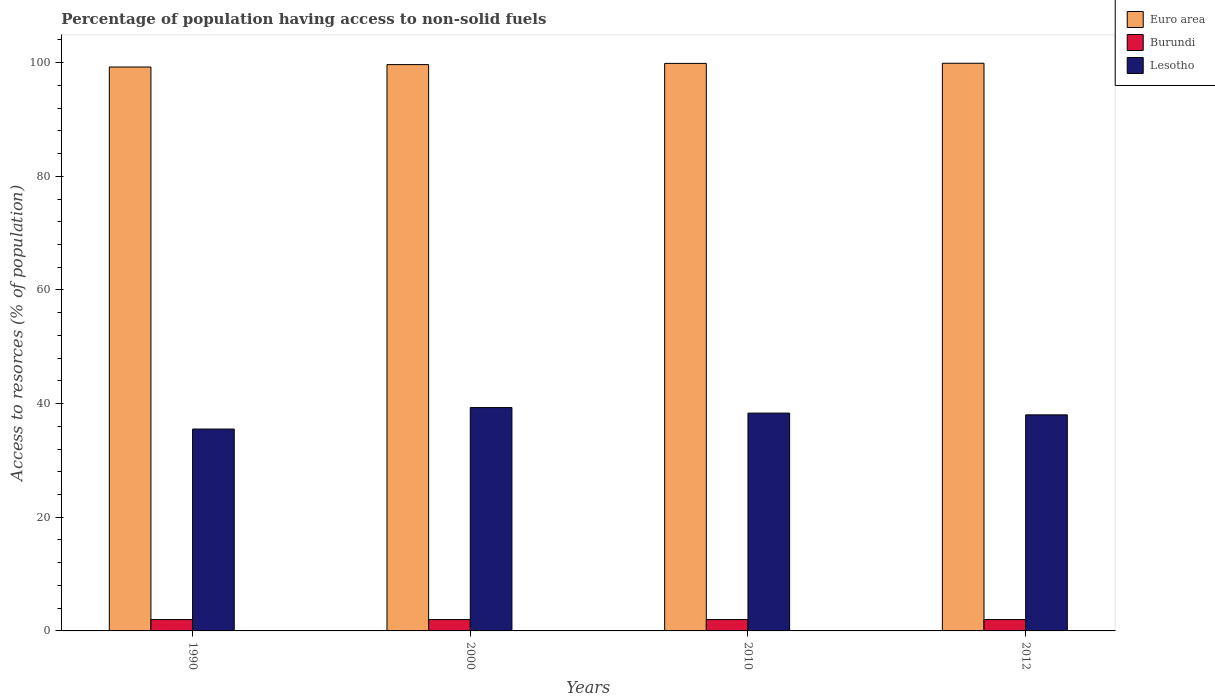How many different coloured bars are there?
Your answer should be very brief. 3. How many groups of bars are there?
Keep it short and to the point. 4. Are the number of bars per tick equal to the number of legend labels?
Provide a short and direct response. Yes. What is the label of the 4th group of bars from the left?
Your response must be concise. 2012. In how many cases, is the number of bars for a given year not equal to the number of legend labels?
Your answer should be compact. 0. What is the percentage of population having access to non-solid fuels in Burundi in 2010?
Provide a succinct answer. 2. Across all years, what is the maximum percentage of population having access to non-solid fuels in Euro area?
Provide a succinct answer. 99.89. Across all years, what is the minimum percentage of population having access to non-solid fuels in Burundi?
Your response must be concise. 2. What is the total percentage of population having access to non-solid fuels in Euro area in the graph?
Your response must be concise. 398.65. What is the difference between the percentage of population having access to non-solid fuels in Lesotho in 2010 and that in 2012?
Offer a terse response. 0.31. What is the difference between the percentage of population having access to non-solid fuels in Burundi in 2012 and the percentage of population having access to non-solid fuels in Lesotho in 1990?
Ensure brevity in your answer.  -33.52. What is the average percentage of population having access to non-solid fuels in Euro area per year?
Offer a terse response. 99.66. In the year 2010, what is the difference between the percentage of population having access to non-solid fuels in Burundi and percentage of population having access to non-solid fuels in Lesotho?
Make the answer very short. -36.33. Is the percentage of population having access to non-solid fuels in Lesotho in 2000 less than that in 2012?
Your response must be concise. No. Is the difference between the percentage of population having access to non-solid fuels in Burundi in 1990 and 2012 greater than the difference between the percentage of population having access to non-solid fuels in Lesotho in 1990 and 2012?
Provide a succinct answer. Yes. What is the difference between the highest and the lowest percentage of population having access to non-solid fuels in Lesotho?
Offer a very short reply. 3.78. Is the sum of the percentage of population having access to non-solid fuels in Euro area in 2010 and 2012 greater than the maximum percentage of population having access to non-solid fuels in Burundi across all years?
Give a very brief answer. Yes. What does the 1st bar from the right in 2010 represents?
Provide a short and direct response. Lesotho. Is it the case that in every year, the sum of the percentage of population having access to non-solid fuels in Burundi and percentage of population having access to non-solid fuels in Lesotho is greater than the percentage of population having access to non-solid fuels in Euro area?
Keep it short and to the point. No. What is the difference between two consecutive major ticks on the Y-axis?
Your response must be concise. 20. Are the values on the major ticks of Y-axis written in scientific E-notation?
Provide a succinct answer. No. What is the title of the graph?
Your response must be concise. Percentage of population having access to non-solid fuels. Does "Micronesia" appear as one of the legend labels in the graph?
Keep it short and to the point. No. What is the label or title of the Y-axis?
Make the answer very short. Access to resorces (% of population). What is the Access to resorces (% of population) of Euro area in 1990?
Offer a very short reply. 99.23. What is the Access to resorces (% of population) in Burundi in 1990?
Give a very brief answer. 2. What is the Access to resorces (% of population) of Lesotho in 1990?
Your answer should be very brief. 35.52. What is the Access to resorces (% of population) in Euro area in 2000?
Your response must be concise. 99.66. What is the Access to resorces (% of population) in Burundi in 2000?
Offer a terse response. 2. What is the Access to resorces (% of population) in Lesotho in 2000?
Provide a short and direct response. 39.3. What is the Access to resorces (% of population) in Euro area in 2010?
Provide a short and direct response. 99.87. What is the Access to resorces (% of population) of Burundi in 2010?
Keep it short and to the point. 2. What is the Access to resorces (% of population) in Lesotho in 2010?
Ensure brevity in your answer.  38.33. What is the Access to resorces (% of population) in Euro area in 2012?
Keep it short and to the point. 99.89. What is the Access to resorces (% of population) in Burundi in 2012?
Keep it short and to the point. 2. What is the Access to resorces (% of population) in Lesotho in 2012?
Make the answer very short. 38.02. Across all years, what is the maximum Access to resorces (% of population) of Euro area?
Offer a very short reply. 99.89. Across all years, what is the maximum Access to resorces (% of population) of Burundi?
Offer a very short reply. 2. Across all years, what is the maximum Access to resorces (% of population) of Lesotho?
Give a very brief answer. 39.3. Across all years, what is the minimum Access to resorces (% of population) of Euro area?
Provide a succinct answer. 99.23. Across all years, what is the minimum Access to resorces (% of population) in Burundi?
Make the answer very short. 2. Across all years, what is the minimum Access to resorces (% of population) of Lesotho?
Provide a short and direct response. 35.52. What is the total Access to resorces (% of population) in Euro area in the graph?
Your response must be concise. 398.65. What is the total Access to resorces (% of population) in Lesotho in the graph?
Keep it short and to the point. 151.18. What is the difference between the Access to resorces (% of population) of Euro area in 1990 and that in 2000?
Keep it short and to the point. -0.42. What is the difference between the Access to resorces (% of population) of Lesotho in 1990 and that in 2000?
Provide a succinct answer. -3.78. What is the difference between the Access to resorces (% of population) in Euro area in 1990 and that in 2010?
Your answer should be compact. -0.64. What is the difference between the Access to resorces (% of population) of Burundi in 1990 and that in 2010?
Ensure brevity in your answer.  0. What is the difference between the Access to resorces (% of population) in Lesotho in 1990 and that in 2010?
Give a very brief answer. -2.81. What is the difference between the Access to resorces (% of population) of Euro area in 1990 and that in 2012?
Provide a succinct answer. -0.66. What is the difference between the Access to resorces (% of population) of Burundi in 1990 and that in 2012?
Your answer should be very brief. 0. What is the difference between the Access to resorces (% of population) of Lesotho in 1990 and that in 2012?
Offer a terse response. -2.5. What is the difference between the Access to resorces (% of population) in Euro area in 2000 and that in 2010?
Ensure brevity in your answer.  -0.21. What is the difference between the Access to resorces (% of population) of Lesotho in 2000 and that in 2010?
Give a very brief answer. 0.97. What is the difference between the Access to resorces (% of population) in Euro area in 2000 and that in 2012?
Offer a very short reply. -0.24. What is the difference between the Access to resorces (% of population) in Lesotho in 2000 and that in 2012?
Your response must be concise. 1.28. What is the difference between the Access to resorces (% of population) in Euro area in 2010 and that in 2012?
Your response must be concise. -0.02. What is the difference between the Access to resorces (% of population) in Burundi in 2010 and that in 2012?
Offer a very short reply. 0. What is the difference between the Access to resorces (% of population) of Lesotho in 2010 and that in 2012?
Your answer should be compact. 0.31. What is the difference between the Access to resorces (% of population) in Euro area in 1990 and the Access to resorces (% of population) in Burundi in 2000?
Offer a very short reply. 97.23. What is the difference between the Access to resorces (% of population) of Euro area in 1990 and the Access to resorces (% of population) of Lesotho in 2000?
Provide a short and direct response. 59.93. What is the difference between the Access to resorces (% of population) of Burundi in 1990 and the Access to resorces (% of population) of Lesotho in 2000?
Provide a short and direct response. -37.3. What is the difference between the Access to resorces (% of population) in Euro area in 1990 and the Access to resorces (% of population) in Burundi in 2010?
Your answer should be compact. 97.23. What is the difference between the Access to resorces (% of population) of Euro area in 1990 and the Access to resorces (% of population) of Lesotho in 2010?
Offer a terse response. 60.9. What is the difference between the Access to resorces (% of population) of Burundi in 1990 and the Access to resorces (% of population) of Lesotho in 2010?
Offer a terse response. -36.33. What is the difference between the Access to resorces (% of population) in Euro area in 1990 and the Access to resorces (% of population) in Burundi in 2012?
Make the answer very short. 97.23. What is the difference between the Access to resorces (% of population) in Euro area in 1990 and the Access to resorces (% of population) in Lesotho in 2012?
Provide a short and direct response. 61.21. What is the difference between the Access to resorces (% of population) of Burundi in 1990 and the Access to resorces (% of population) of Lesotho in 2012?
Make the answer very short. -36.02. What is the difference between the Access to resorces (% of population) in Euro area in 2000 and the Access to resorces (% of population) in Burundi in 2010?
Ensure brevity in your answer.  97.66. What is the difference between the Access to resorces (% of population) in Euro area in 2000 and the Access to resorces (% of population) in Lesotho in 2010?
Give a very brief answer. 61.33. What is the difference between the Access to resorces (% of population) in Burundi in 2000 and the Access to resorces (% of population) in Lesotho in 2010?
Your response must be concise. -36.33. What is the difference between the Access to resorces (% of population) in Euro area in 2000 and the Access to resorces (% of population) in Burundi in 2012?
Provide a succinct answer. 97.66. What is the difference between the Access to resorces (% of population) of Euro area in 2000 and the Access to resorces (% of population) of Lesotho in 2012?
Offer a terse response. 61.63. What is the difference between the Access to resorces (% of population) in Burundi in 2000 and the Access to resorces (% of population) in Lesotho in 2012?
Offer a very short reply. -36.02. What is the difference between the Access to resorces (% of population) in Euro area in 2010 and the Access to resorces (% of population) in Burundi in 2012?
Offer a very short reply. 97.87. What is the difference between the Access to resorces (% of population) in Euro area in 2010 and the Access to resorces (% of population) in Lesotho in 2012?
Offer a terse response. 61.85. What is the difference between the Access to resorces (% of population) of Burundi in 2010 and the Access to resorces (% of population) of Lesotho in 2012?
Offer a terse response. -36.02. What is the average Access to resorces (% of population) in Euro area per year?
Give a very brief answer. 99.66. What is the average Access to resorces (% of population) of Burundi per year?
Make the answer very short. 2. What is the average Access to resorces (% of population) of Lesotho per year?
Provide a short and direct response. 37.79. In the year 1990, what is the difference between the Access to resorces (% of population) of Euro area and Access to resorces (% of population) of Burundi?
Your response must be concise. 97.23. In the year 1990, what is the difference between the Access to resorces (% of population) in Euro area and Access to resorces (% of population) in Lesotho?
Provide a short and direct response. 63.71. In the year 1990, what is the difference between the Access to resorces (% of population) in Burundi and Access to resorces (% of population) in Lesotho?
Make the answer very short. -33.52. In the year 2000, what is the difference between the Access to resorces (% of population) in Euro area and Access to resorces (% of population) in Burundi?
Your response must be concise. 97.66. In the year 2000, what is the difference between the Access to resorces (% of population) of Euro area and Access to resorces (% of population) of Lesotho?
Give a very brief answer. 60.35. In the year 2000, what is the difference between the Access to resorces (% of population) in Burundi and Access to resorces (% of population) in Lesotho?
Provide a short and direct response. -37.3. In the year 2010, what is the difference between the Access to resorces (% of population) in Euro area and Access to resorces (% of population) in Burundi?
Keep it short and to the point. 97.87. In the year 2010, what is the difference between the Access to resorces (% of population) of Euro area and Access to resorces (% of population) of Lesotho?
Provide a short and direct response. 61.54. In the year 2010, what is the difference between the Access to resorces (% of population) in Burundi and Access to resorces (% of population) in Lesotho?
Your answer should be very brief. -36.33. In the year 2012, what is the difference between the Access to resorces (% of population) of Euro area and Access to resorces (% of population) of Burundi?
Keep it short and to the point. 97.89. In the year 2012, what is the difference between the Access to resorces (% of population) of Euro area and Access to resorces (% of population) of Lesotho?
Keep it short and to the point. 61.87. In the year 2012, what is the difference between the Access to resorces (% of population) in Burundi and Access to resorces (% of population) in Lesotho?
Give a very brief answer. -36.02. What is the ratio of the Access to resorces (% of population) in Lesotho in 1990 to that in 2000?
Ensure brevity in your answer.  0.9. What is the ratio of the Access to resorces (% of population) in Lesotho in 1990 to that in 2010?
Your answer should be compact. 0.93. What is the ratio of the Access to resorces (% of population) of Lesotho in 1990 to that in 2012?
Your response must be concise. 0.93. What is the ratio of the Access to resorces (% of population) of Lesotho in 2000 to that in 2010?
Make the answer very short. 1.03. What is the ratio of the Access to resorces (% of population) in Euro area in 2000 to that in 2012?
Keep it short and to the point. 1. What is the ratio of the Access to resorces (% of population) in Lesotho in 2000 to that in 2012?
Provide a succinct answer. 1.03. What is the ratio of the Access to resorces (% of population) in Euro area in 2010 to that in 2012?
Make the answer very short. 1. What is the ratio of the Access to resorces (% of population) of Burundi in 2010 to that in 2012?
Ensure brevity in your answer.  1. What is the ratio of the Access to resorces (% of population) in Lesotho in 2010 to that in 2012?
Provide a succinct answer. 1.01. What is the difference between the highest and the second highest Access to resorces (% of population) of Euro area?
Offer a terse response. 0.02. What is the difference between the highest and the second highest Access to resorces (% of population) in Burundi?
Give a very brief answer. 0. What is the difference between the highest and the second highest Access to resorces (% of population) in Lesotho?
Your answer should be compact. 0.97. What is the difference between the highest and the lowest Access to resorces (% of population) of Euro area?
Your answer should be very brief. 0.66. What is the difference between the highest and the lowest Access to resorces (% of population) in Burundi?
Make the answer very short. 0. What is the difference between the highest and the lowest Access to resorces (% of population) of Lesotho?
Your answer should be very brief. 3.78. 